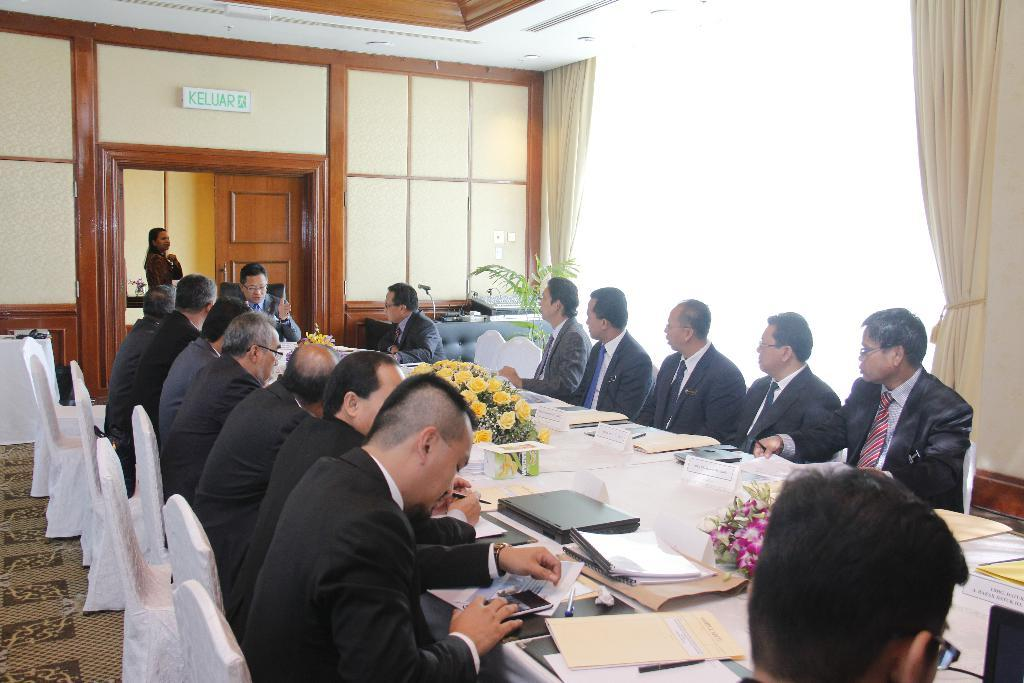How many people are in the room in the image? There are many persons in the room in the image. What are the persons doing in the image? The persons are sitting on chairs in the image. What is in front of the chairs? There is a table in front of the chairs in the image. What can be found on the table? There are many items on the table, including house plants in the image. What type of stamp can be seen on the table in the image? There is no stamp present on the table in the image. What season is depicted in the image? The image does not depict a specific season, as there are no seasonal cues present. 